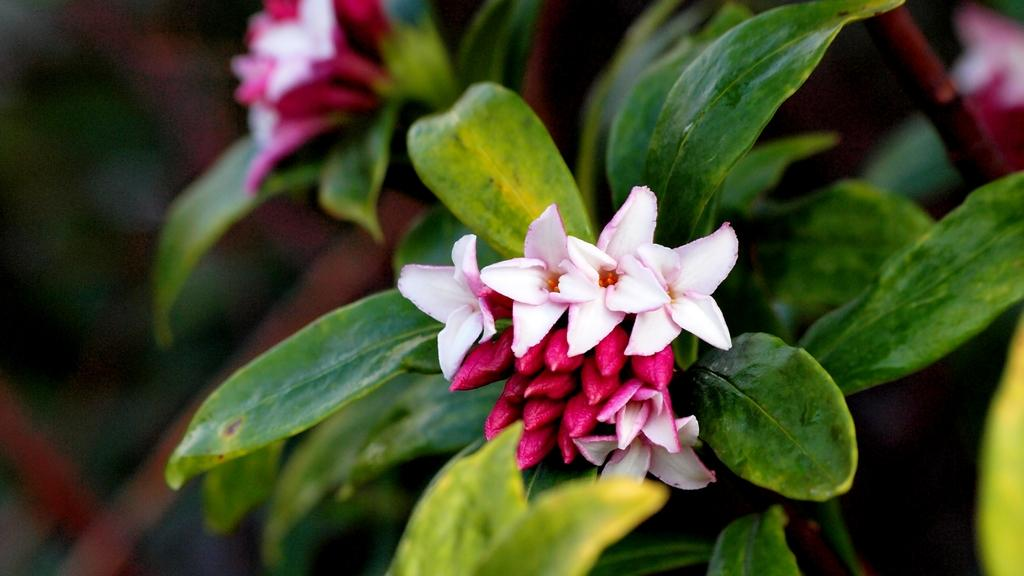What type of plants can be seen in the image? There are flowers and leaves in the image. What can be inferred about the focus of the image? The background of the image is blurred, suggesting that the flowers and leaves are the main focus. What type of brass balls can be seen in the image? There are no brass balls present in the image; it features flowers and leaves with a blurred background. 